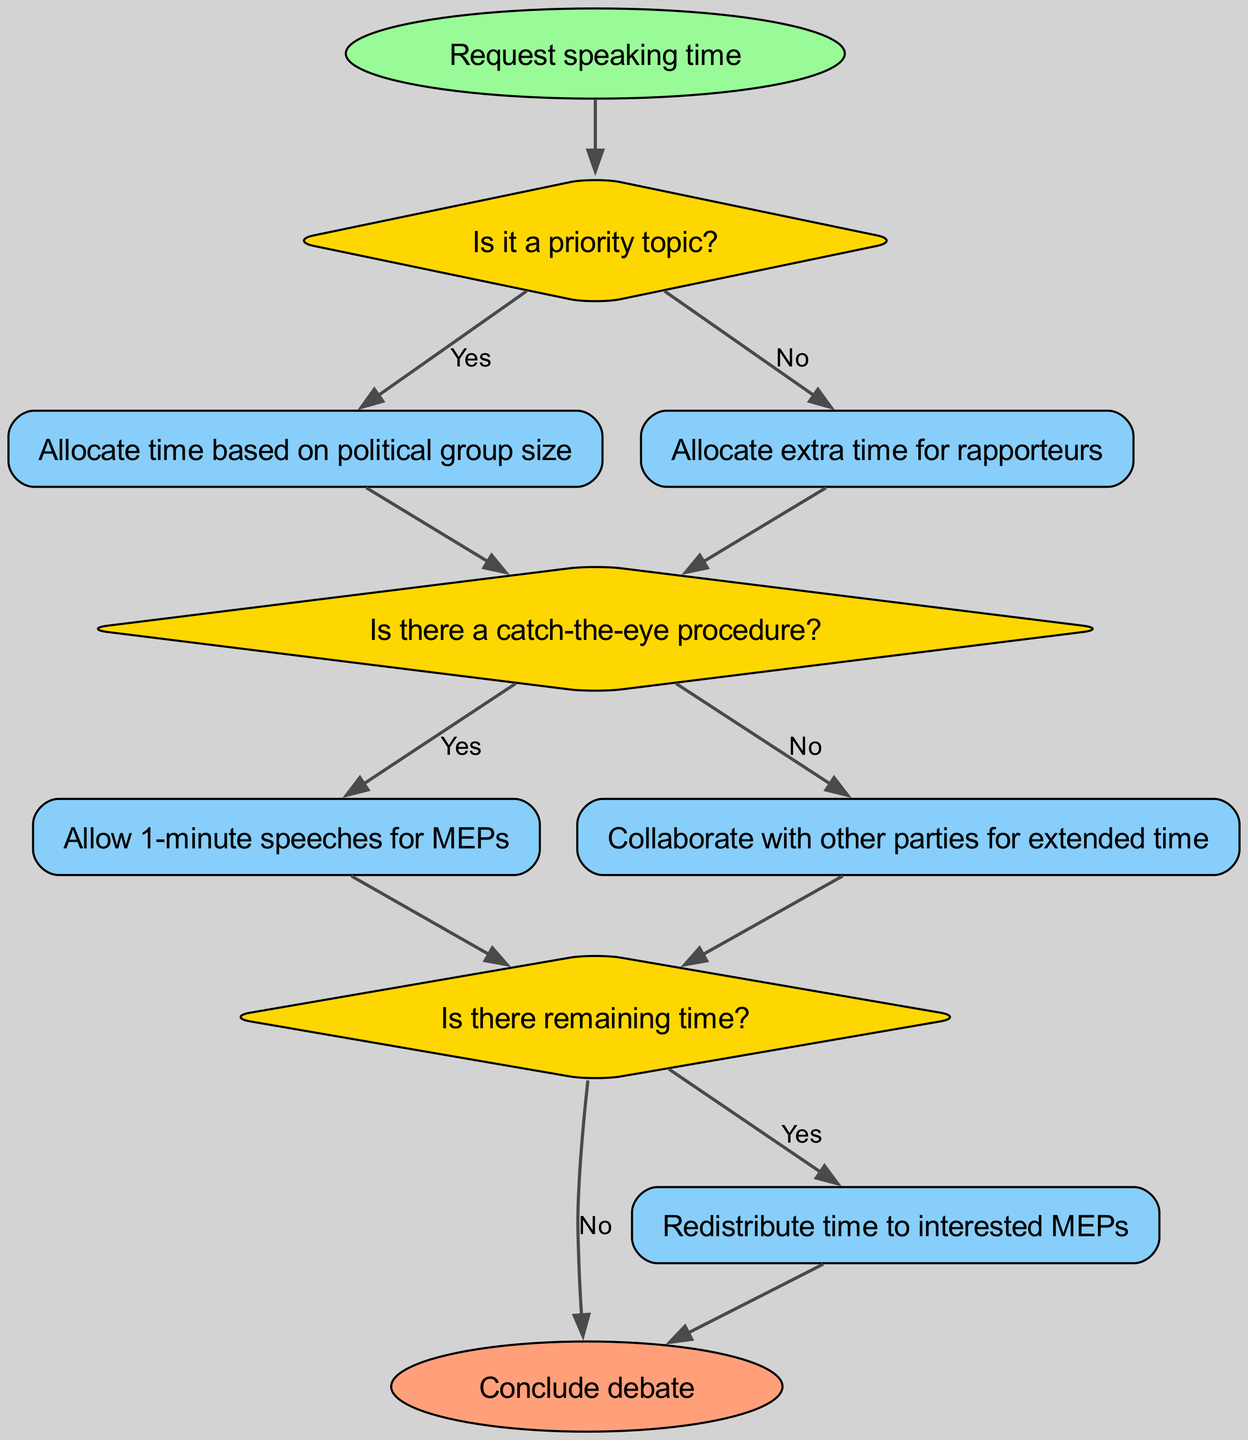What is the first action taken after starting the speaking time allocation? The flow chart starts with the initial action "Request speaking time," which is indicated directly following the start node.
Answer: Request speaking time How many decision nodes are present in the flowchart? The flowchart contains three decision nodes: decision1, decision2, and decision3, indicated by their diamond shapes.
Answer: 3 What happens if the topic is not a priority? If the topic is not a priority, the flow moves to action2 ("Allocate extra time for rapporteurs") as indicated by the "No" edge connecting decision1 to action2.
Answer: Allocate extra time for rapporteurs What is the action taken if there is a "catch-the-eye" procedure? If there is a catch-the-eye procedure, the flow directs to action3, which allows 1-minute speeches for MEPs, indicated by the "Yes" edge from decision2 to action3.
Answer: Allow 1-minute speeches for MEPs If there is remaining time after the catch-the-eye procedure, what action is taken? After reaching decision3, if there is remaining time, the flow leads to action5, which states to redistribute time to interested MEPs, shown by the "Yes" edge from decision3 to action5.
Answer: Redistribute time to interested MEPs What is the outcome if there is no remaining time? If there is no remaining time after decision3, the flow directly connects to the end node, concluding the debate, as indicated by the "No" edge.
Answer: Conclude debate What condition leads to allowing collaboration with other parties for extended time? Collaboration with other parties for extended time happens if there is no catch-the-eye procedure, as indicated by the "No" edge from decision2 to action4.
Answer: No catch-the-eye procedure 